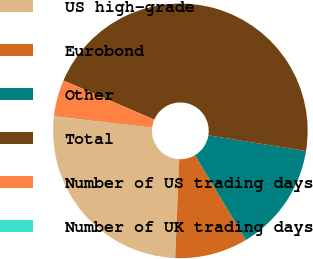Convert chart. <chart><loc_0><loc_0><loc_500><loc_500><pie_chart><fcel>US high-grade<fcel>Eurobond<fcel>Other<fcel>Total<fcel>Number of US trading days<fcel>Number of UK trading days<nl><fcel>26.14%<fcel>9.25%<fcel>13.85%<fcel>46.07%<fcel>4.65%<fcel>0.04%<nl></chart> 